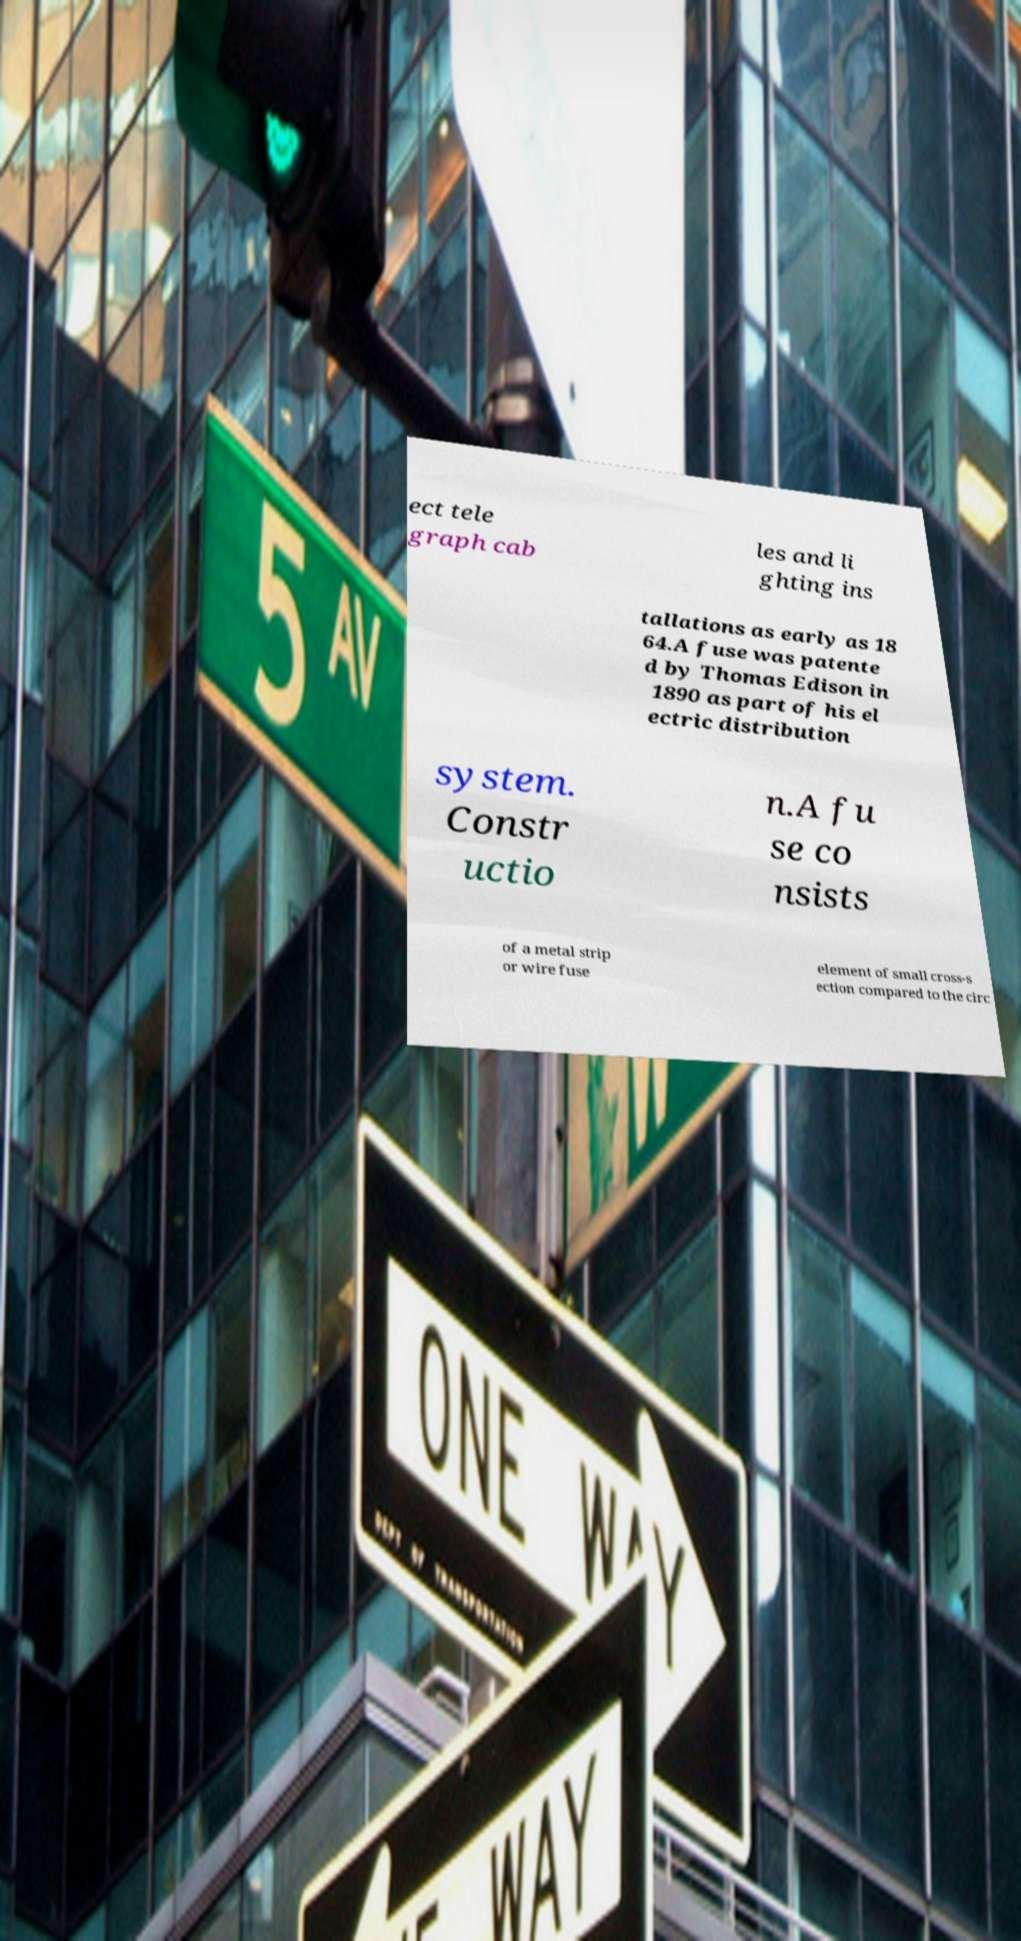What messages or text are displayed in this image? I need them in a readable, typed format. ect tele graph cab les and li ghting ins tallations as early as 18 64.A fuse was patente d by Thomas Edison in 1890 as part of his el ectric distribution system. Constr uctio n.A fu se co nsists of a metal strip or wire fuse element of small cross-s ection compared to the circ 